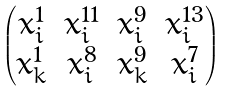Convert formula to latex. <formula><loc_0><loc_0><loc_500><loc_500>\begin{pmatrix} x _ { i } ^ { 1 } & x _ { i } ^ { 1 1 } & x _ { i } ^ { 9 } & x _ { i } ^ { 1 3 } \\ x _ { k } ^ { 1 } & x _ { i } ^ { 8 } & x _ { k } ^ { 9 } & x _ { i } ^ { 7 } \end{pmatrix}</formula> 